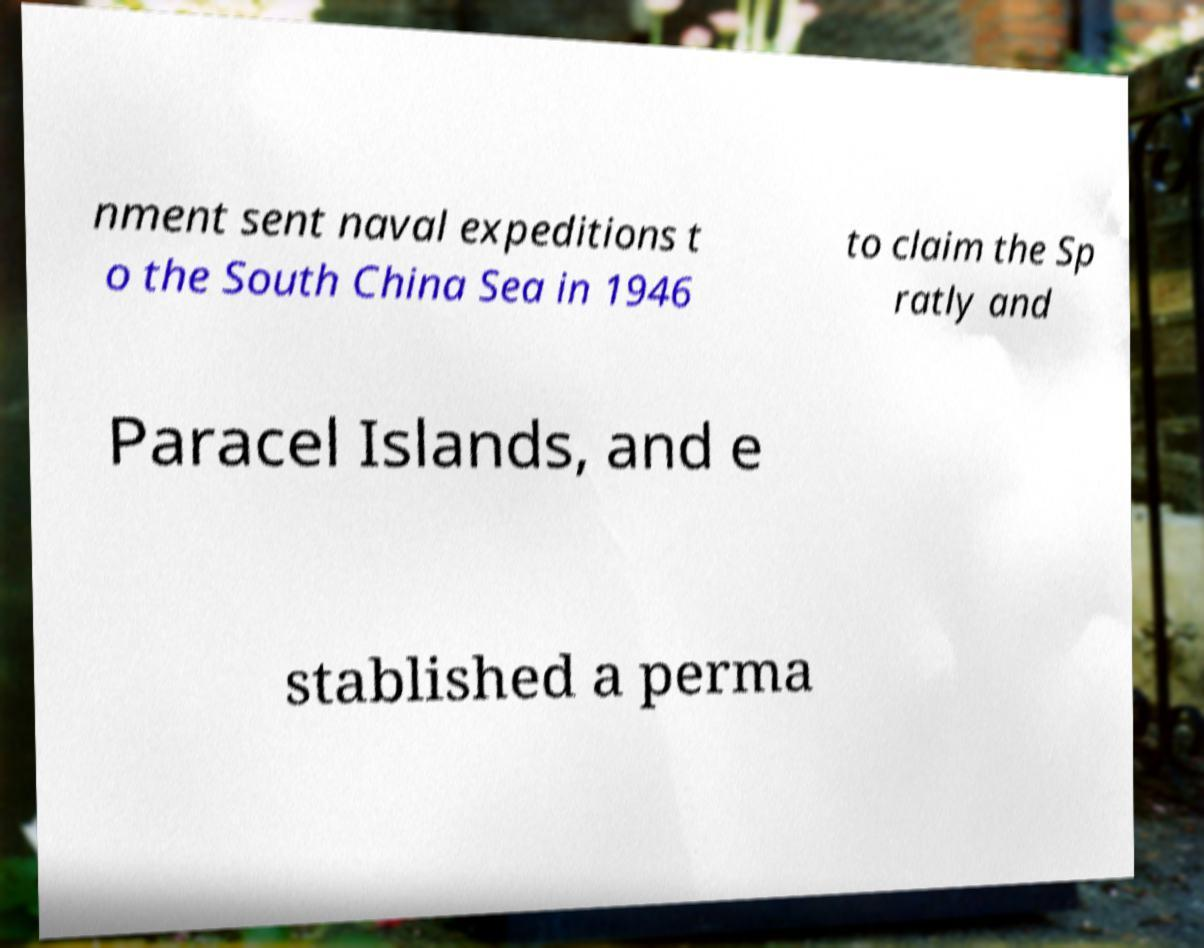What messages or text are displayed in this image? I need them in a readable, typed format. nment sent naval expeditions t o the South China Sea in 1946 to claim the Sp ratly and Paracel Islands, and e stablished a perma 